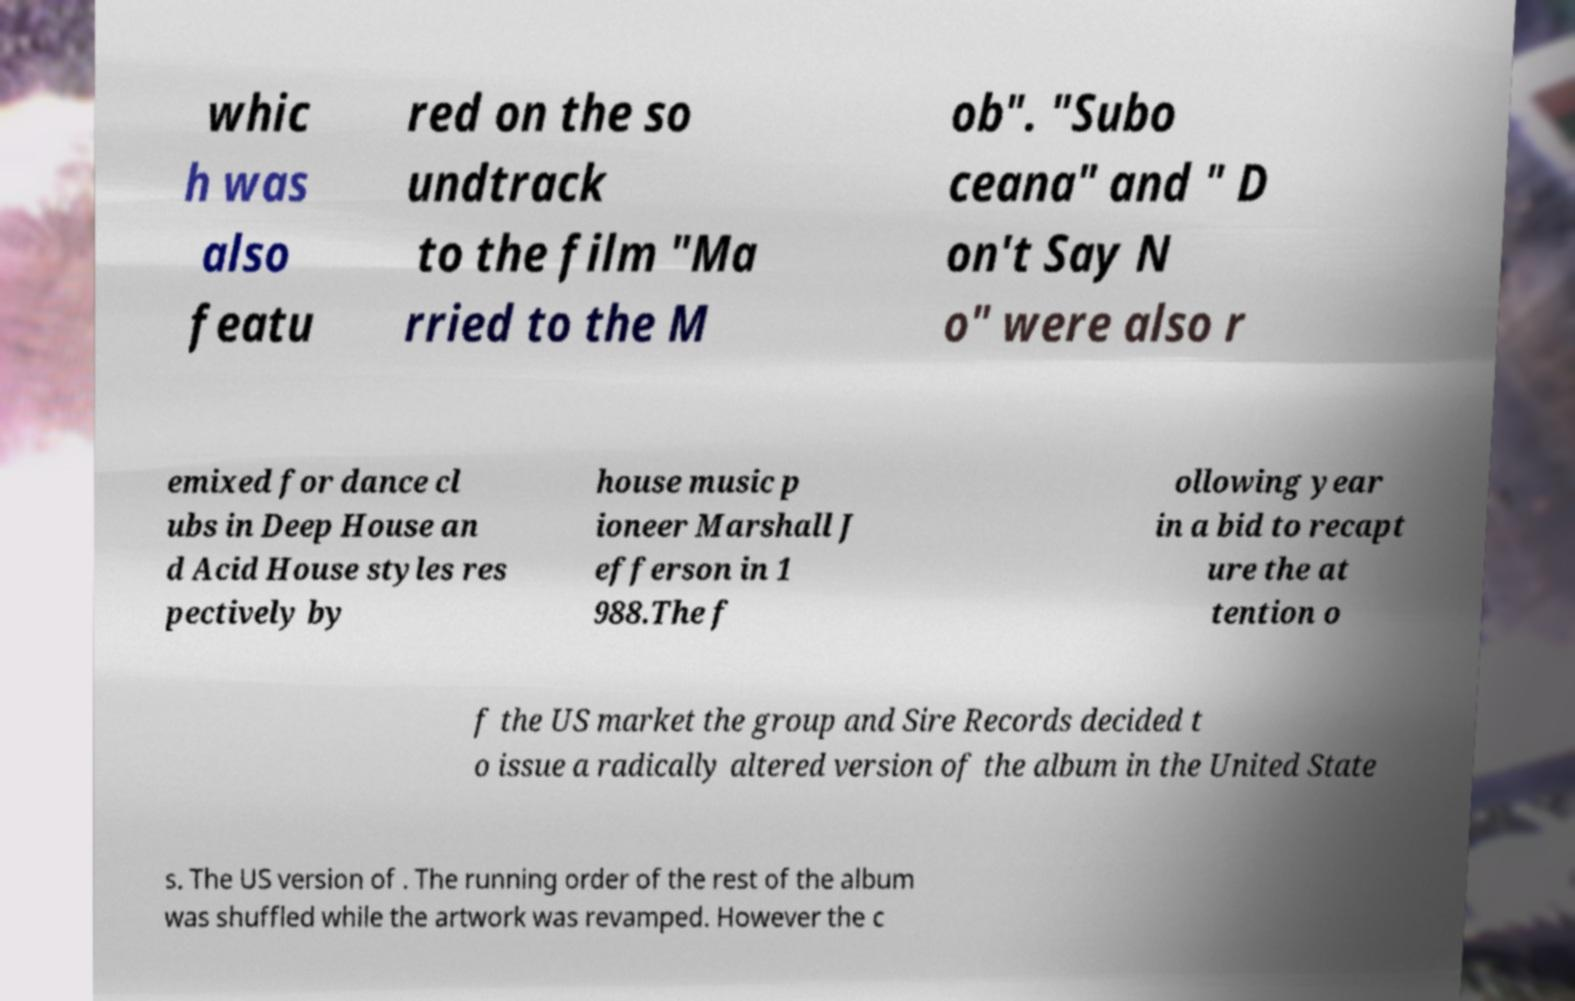Please identify and transcribe the text found in this image. whic h was also featu red on the so undtrack to the film "Ma rried to the M ob". "Subo ceana" and " D on't Say N o" were also r emixed for dance cl ubs in Deep House an d Acid House styles res pectively by house music p ioneer Marshall J efferson in 1 988.The f ollowing year in a bid to recapt ure the at tention o f the US market the group and Sire Records decided t o issue a radically altered version of the album in the United State s. The US version of . The running order of the rest of the album was shuffled while the artwork was revamped. However the c 